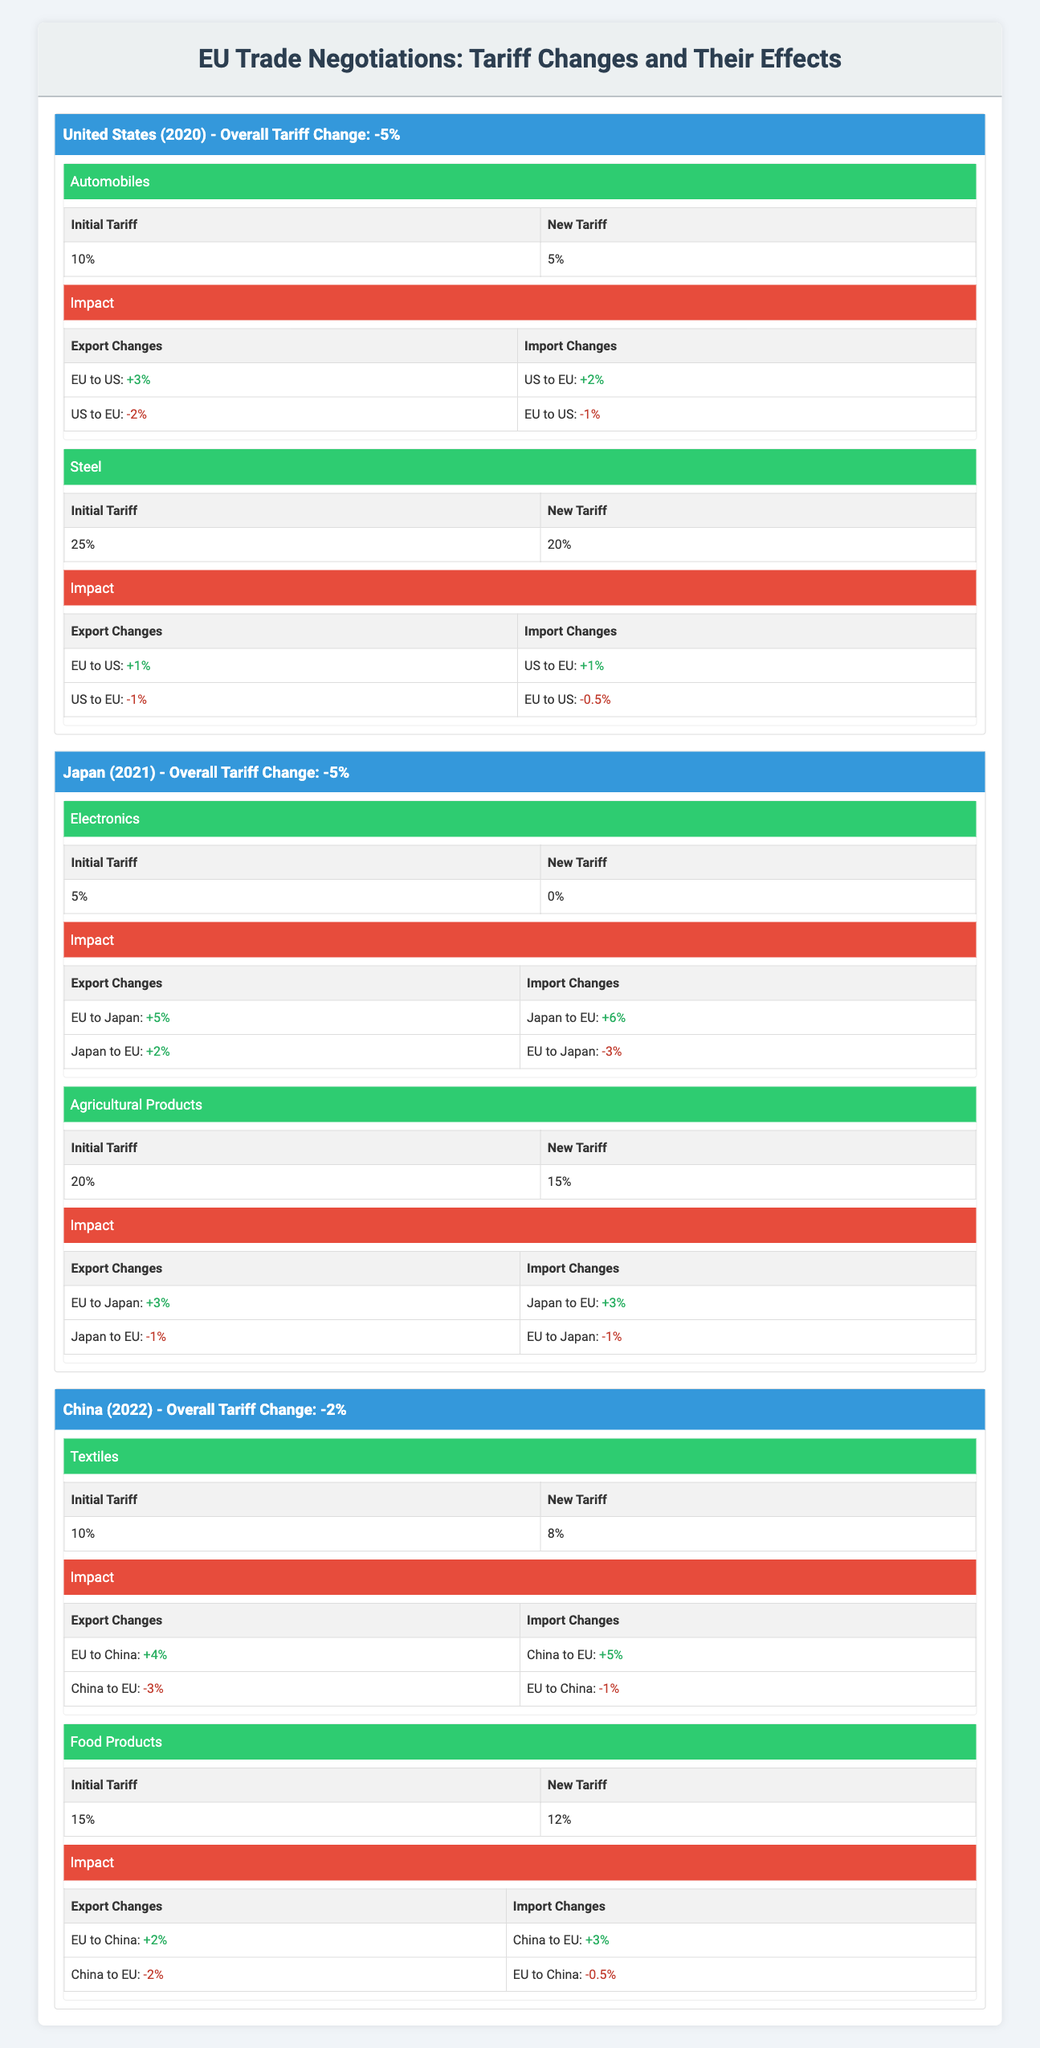What was the total tariff change percentage for the United States in 2020? The tariff change for the United States in 2020 is explicitly stated as -5%.
Answer: -5% Which product category saw the largest reduction in tariff when trading with Japan in 2021? The tariff on electronics decreased from 5% to 0%, a total reduction of 5%, while agricultural products decreased from 20% to 15%, a reduction of 5%. Both categories experienced the same percentage reduction, but electronics' final tariff is 0%.
Answer: Electronics Did the changes in tariffs affect export and import volumes positively for EU to Japan in 2021? Yes. The exports to Japan for electronics increased by 5%, and for agricultural products by 3%. Both categories showed positive changes in exports from EU to Japan.
Answer: Yes How much did the EU's agricultural exports to Japan change after the tariff reduction in 2021? Initially, agricultural exports from the EU to Japan were affected positively with an increase of 3% after the tariff was lowered from 20% to 15%. This signifies a favorable change.
Answer: 3% What were the total changes in imports for textiles and food products from China to the EU in 2022? For textiles, imports from China to the EU increased by 5%, and for food products, the increase was 3%. The total changes in imports amount to 5% + 3% = 8%.
Answer: 8% How did the export changes for steel differ between the EU to the US and the US to the EU in 2020? Exports from the EU to the US increased by 1%, while exports from the US to the EU decreased by 1%. This shows a positive change for the EU while the US faced negative changes in exports to the EU.
Answer: EU to US: +1%, US to EU: -1% Was there a negative impact on the imports of food products from China to the EU in 2022? Yes, imports of food products from China to the EU decreased by 2%, indicating a negative impact on imports in this category.
Answer: Yes Which trade partner had a total tariff change of 0% and what was the impact on trade in terms of imports and exports? Japan had a total tariff change of 0% in 2021, with exports to Japan increasing by 5% for electronics and 3% for agricultural products; imports also seen positive changes.
Answer: Japan; positive changes in imports and exports 